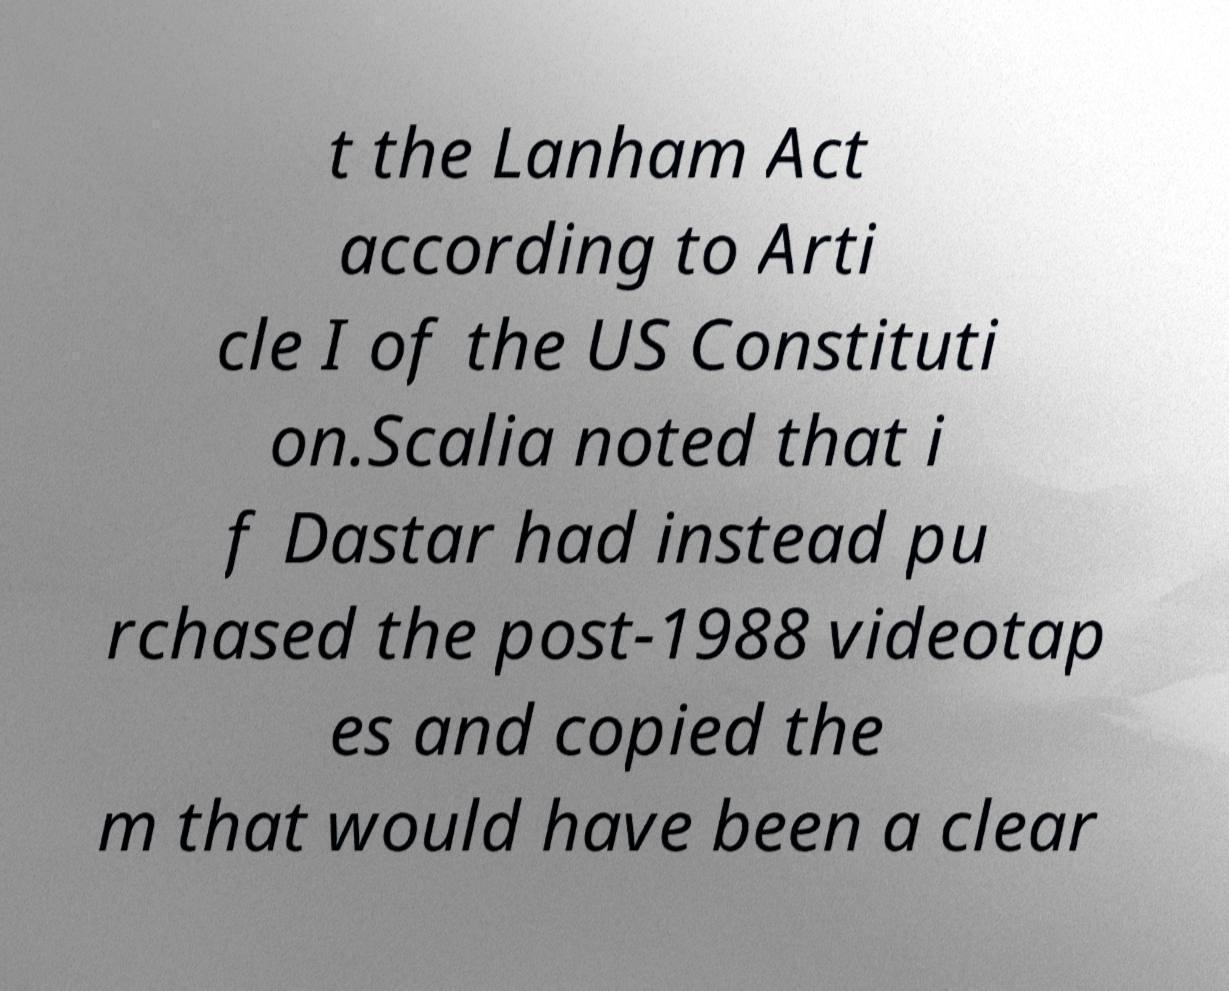For documentation purposes, I need the text within this image transcribed. Could you provide that? t the Lanham Act according to Arti cle I of the US Constituti on.Scalia noted that i f Dastar had instead pu rchased the post-1988 videotap es and copied the m that would have been a clear 